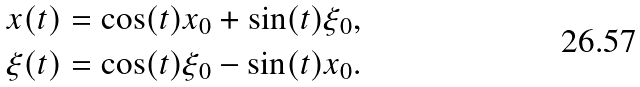<formula> <loc_0><loc_0><loc_500><loc_500>x ( t ) & = \cos ( t ) x _ { 0 } + \sin ( t ) \xi _ { 0 } , \\ \xi ( t ) & = \cos ( t ) \xi _ { 0 } - \sin ( t ) x _ { 0 } .</formula> 